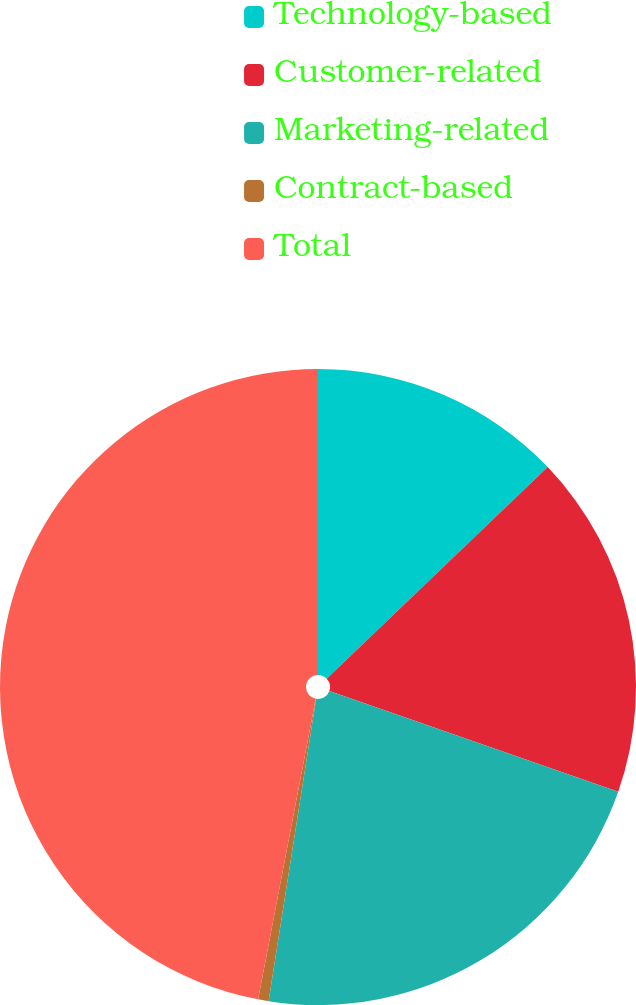<chart> <loc_0><loc_0><loc_500><loc_500><pie_chart><fcel>Technology-based<fcel>Customer-related<fcel>Marketing-related<fcel>Contract-based<fcel>Total<nl><fcel>12.85%<fcel>17.5%<fcel>22.14%<fcel>0.53%<fcel>46.99%<nl></chart> 